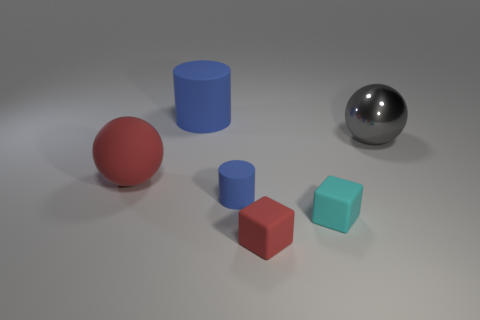Is the material of the red object on the left side of the large blue cylinder the same as the large cylinder? Based on the visual similarities in their appearance, the red object and the large blue cylinder seem to be made of the same matte material, which diffuses light rather uniformly, suggesting a non-glossy texture. 